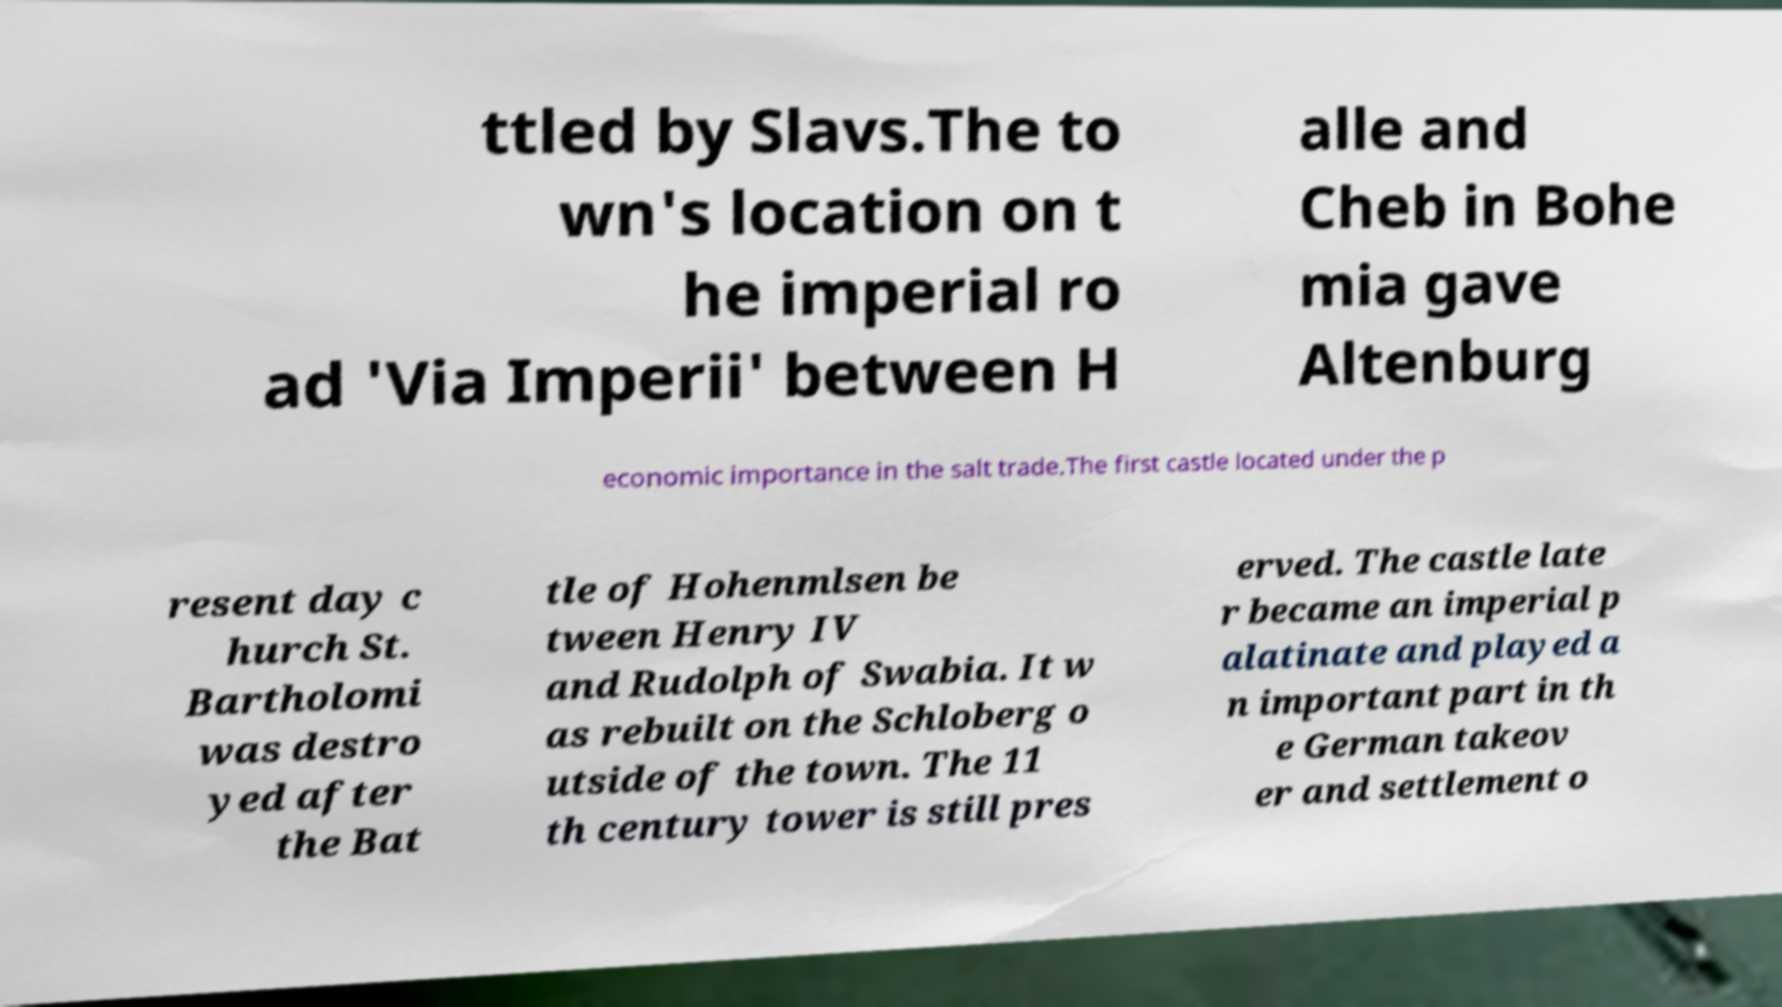Can you read and provide the text displayed in the image?This photo seems to have some interesting text. Can you extract and type it out for me? ttled by Slavs.The to wn's location on t he imperial ro ad 'Via Imperii' between H alle and Cheb in Bohe mia gave Altenburg economic importance in the salt trade.The first castle located under the p resent day c hurch St. Bartholomi was destro yed after the Bat tle of Hohenmlsen be tween Henry IV and Rudolph of Swabia. It w as rebuilt on the Schloberg o utside of the town. The 11 th century tower is still pres erved. The castle late r became an imperial p alatinate and played a n important part in th e German takeov er and settlement o 